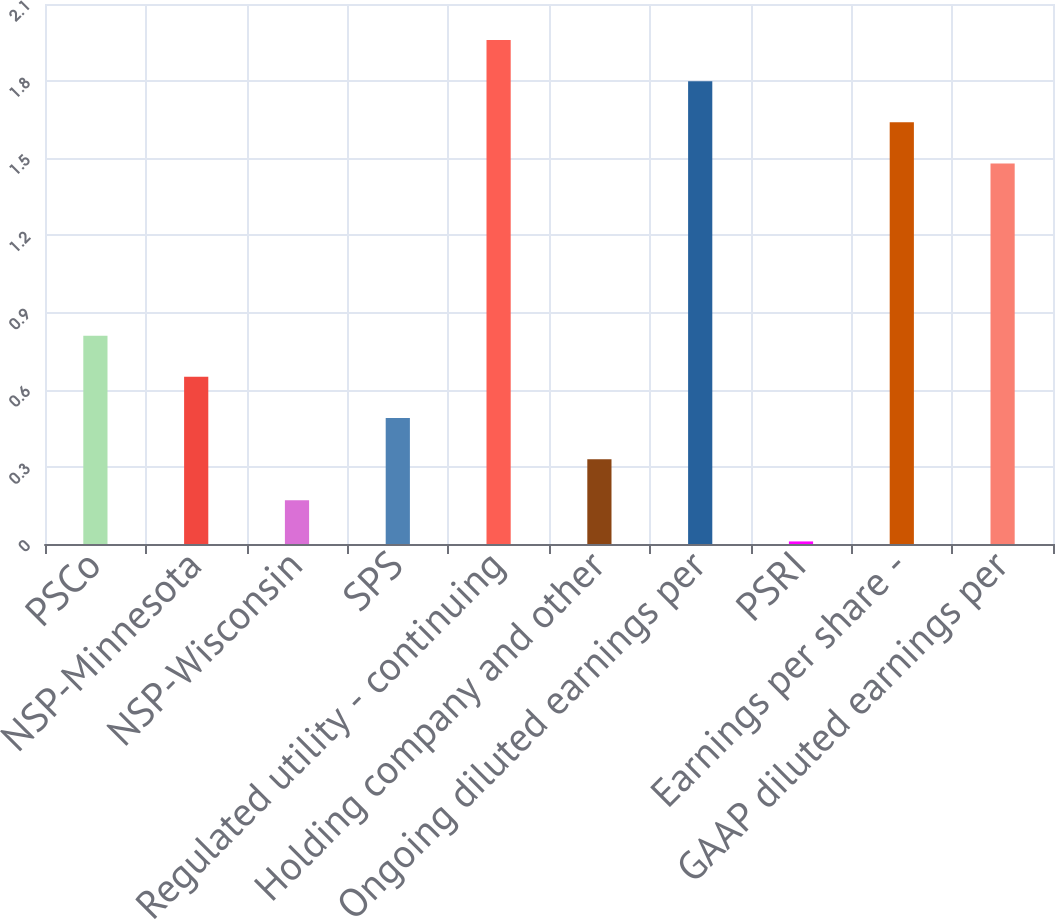<chart> <loc_0><loc_0><loc_500><loc_500><bar_chart><fcel>PSCo<fcel>NSP-Minnesota<fcel>NSP-Wisconsin<fcel>SPS<fcel>Regulated utility - continuing<fcel>Holding company and other<fcel>Ongoing diluted earnings per<fcel>PSRI<fcel>Earnings per share -<fcel>GAAP diluted earnings per<nl><fcel>0.81<fcel>0.65<fcel>0.17<fcel>0.49<fcel>1.96<fcel>0.33<fcel>1.8<fcel>0.01<fcel>1.64<fcel>1.48<nl></chart> 